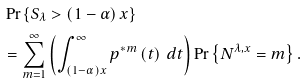Convert formula to latex. <formula><loc_0><loc_0><loc_500><loc_500>& \Pr \left \{ S _ { \lambda } > \left ( 1 - \alpha \right ) x \right \} \\ & = \sum _ { m = 1 } ^ { \infty } \left ( \int _ { \left ( 1 - \alpha \right ) x } ^ { \infty } p ^ { \ast m } \left ( t \right ) \, d t \right ) \Pr \left \{ N ^ { \lambda , x } = m \right \} .</formula> 